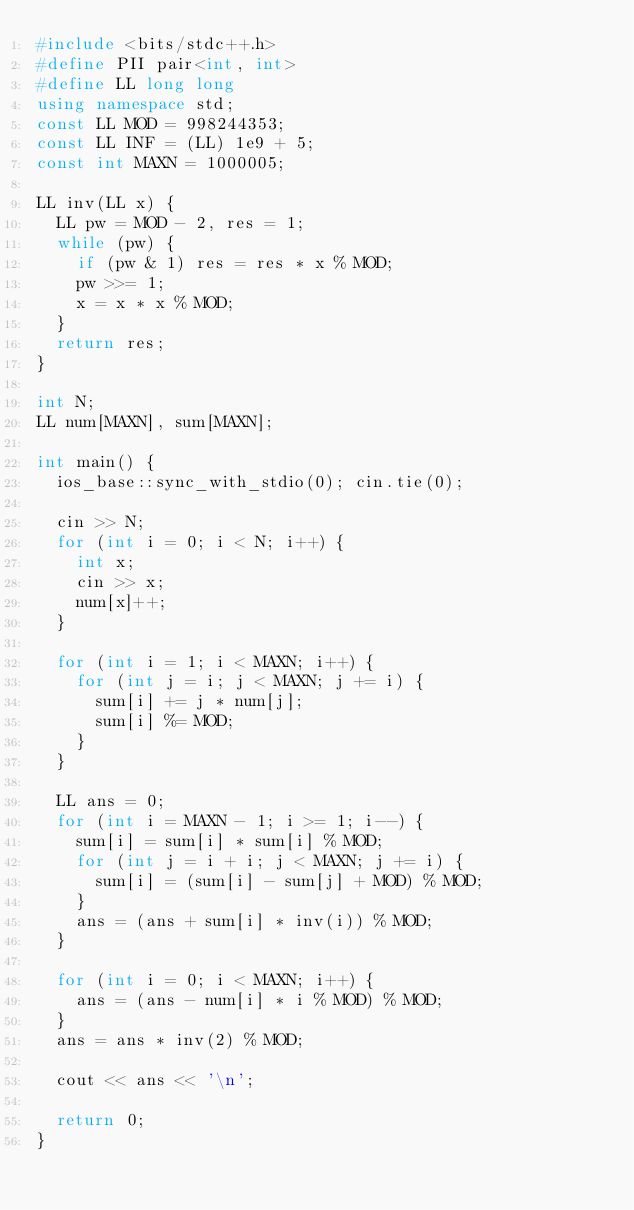Convert code to text. <code><loc_0><loc_0><loc_500><loc_500><_C++_>#include <bits/stdc++.h>
#define PII pair<int, int>
#define LL long long
using namespace std;
const LL MOD = 998244353;
const LL INF = (LL) 1e9 + 5;
const int MAXN = 1000005;

LL inv(LL x) {
	LL pw = MOD - 2, res = 1;
	while (pw) {
		if (pw & 1) res = res * x % MOD;
		pw >>= 1;
		x = x * x % MOD;
	}
	return res;
}

int N;
LL num[MAXN], sum[MAXN];

int main() {
	ios_base::sync_with_stdio(0); cin.tie(0);

	cin >> N;
	for (int i = 0; i < N; i++) {
		int x;
		cin >> x;
		num[x]++;
	}
	
	for (int i = 1; i < MAXN; i++) {
		for (int j = i; j < MAXN; j += i) {
			sum[i] += j * num[j];
			sum[i] %= MOD;
		}
	}
	
	LL ans = 0;
	for (int i = MAXN - 1; i >= 1; i--) {
		sum[i] = sum[i] * sum[i] % MOD;
		for (int j = i + i; j < MAXN; j += i) {
			sum[i] = (sum[i] - sum[j] + MOD) % MOD;
		}
		ans = (ans + sum[i] * inv(i)) % MOD;
	}
	
	for (int i = 0; i < MAXN; i++) {
		ans = (ans - num[i] * i % MOD) % MOD;
	}
	ans = ans * inv(2) % MOD;
	
	cout << ans << '\n';

	return 0;
}</code> 